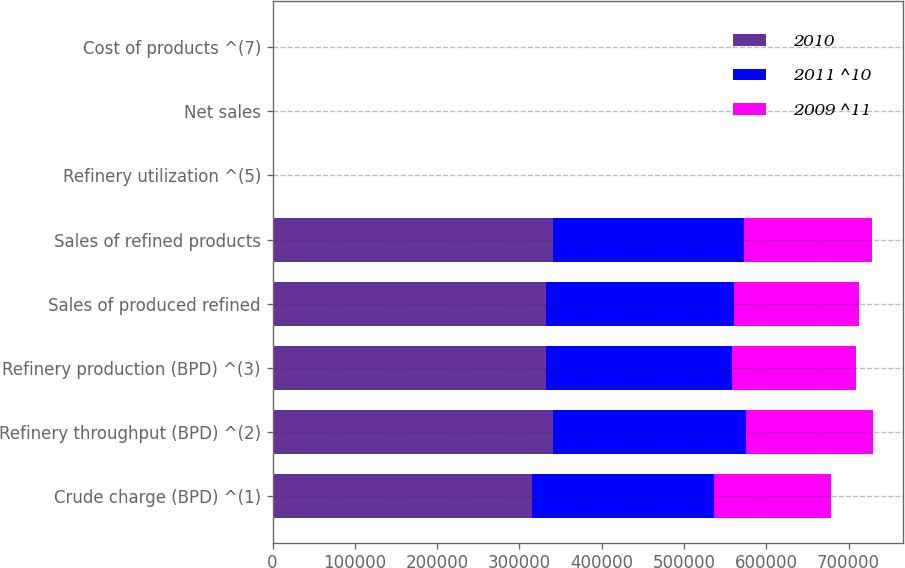Convert chart. <chart><loc_0><loc_0><loc_500><loc_500><stacked_bar_chart><ecel><fcel>Crude charge (BPD) ^(1)<fcel>Refinery throughput (BPD) ^(2)<fcel>Refinery production (BPD) ^(3)<fcel>Sales of produced refined<fcel>Sales of refined products<fcel>Refinery utilization ^(5)<fcel>Net sales<fcel>Cost of products ^(7)<nl><fcel>2010<fcel>315000<fcel>340200<fcel>331890<fcel>332720<fcel>340630<fcel>89.9<fcel>118.82<fcel>98.18<nl><fcel>2011 ^10<fcel>221440<fcel>234910<fcel>225980<fcel>228140<fcel>232100<fcel>86.5<fcel>91.06<fcel>82.27<nl><fcel>2009 ^11<fcel>142430<fcel>154940<fcel>151420<fcel>151580<fcel>155820<fcel>78.9<fcel>74.06<fcel>66.85<nl></chart> 